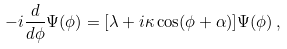<formula> <loc_0><loc_0><loc_500><loc_500>- i \frac { d } { d \phi } \Psi ( \phi ) = [ \lambda + i \kappa \cos ( \phi + \alpha ) ] \Psi ( \phi ) \, ,</formula> 